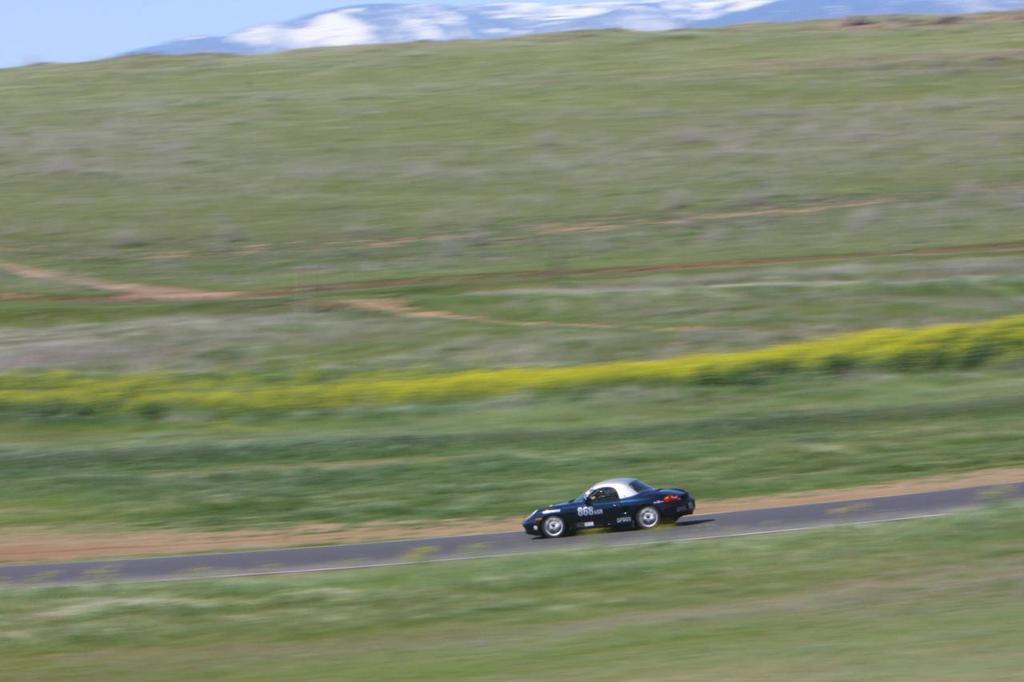How would you summarize this image in a sentence or two? In this picture there is a car which is running on the road. At the bottom we can see the grass. In the background we can see farmland, plants and mountain. At the top left corner we can see sky and clouds. 